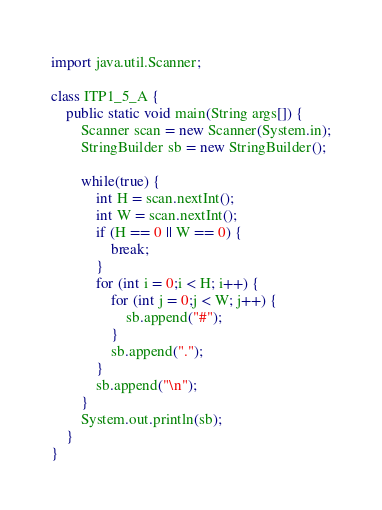Convert code to text. <code><loc_0><loc_0><loc_500><loc_500><_Java_>import java.util.Scanner;

class ITP1_5_A {
    public static void main(String args[]) {
        Scanner scan = new Scanner(System.in);
        StringBuilder sb = new StringBuilder();

        while(true) {
            int H = scan.nextInt();
            int W = scan.nextInt();
            if (H == 0 || W == 0) {
                break;
            }
            for (int i = 0;i < H; i++) {
                for (int j = 0;j < W; j++) {
                    sb.append("#");
                }
                sb.append(".");
            }
            sb.append("\n");
        }
        System.out.println(sb);
    }
}</code> 